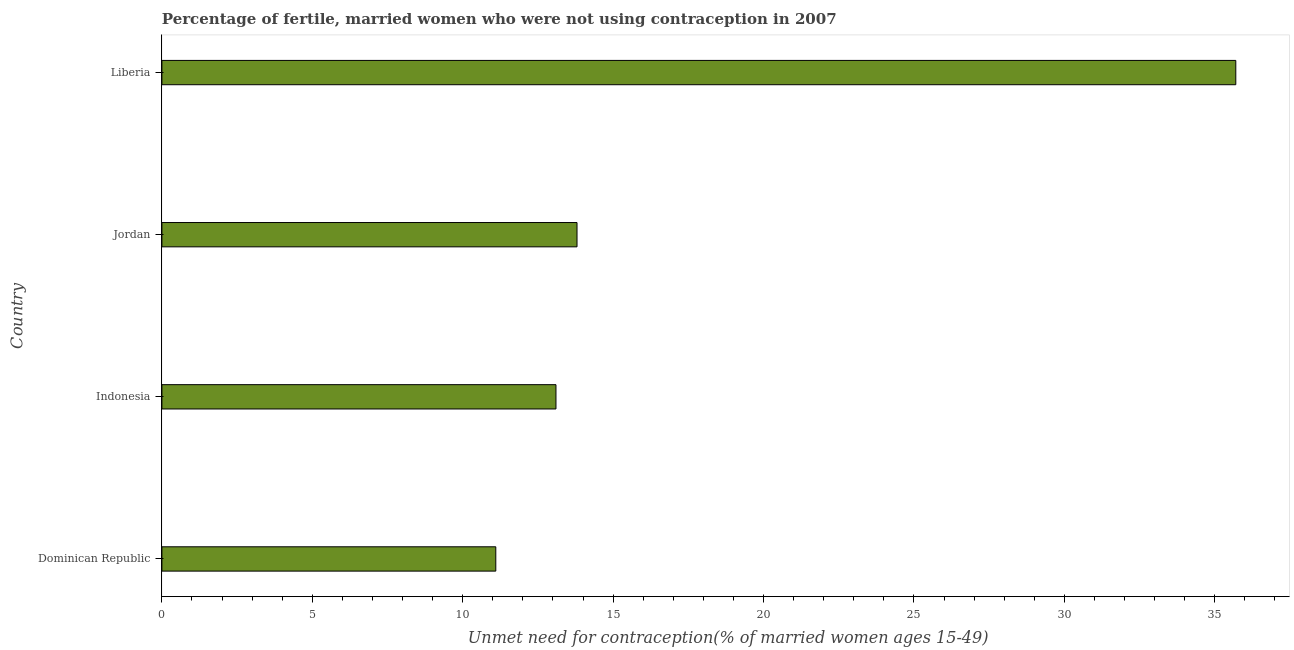Does the graph contain any zero values?
Offer a very short reply. No. What is the title of the graph?
Make the answer very short. Percentage of fertile, married women who were not using contraception in 2007. What is the label or title of the X-axis?
Provide a short and direct response.  Unmet need for contraception(% of married women ages 15-49). Across all countries, what is the maximum number of married women who are not using contraception?
Give a very brief answer. 35.7. In which country was the number of married women who are not using contraception maximum?
Offer a very short reply. Liberia. In which country was the number of married women who are not using contraception minimum?
Keep it short and to the point. Dominican Republic. What is the sum of the number of married women who are not using contraception?
Give a very brief answer. 73.7. What is the average number of married women who are not using contraception per country?
Provide a succinct answer. 18.43. What is the median number of married women who are not using contraception?
Your answer should be very brief. 13.45. In how many countries, is the number of married women who are not using contraception greater than 29 %?
Your answer should be compact. 1. What is the ratio of the number of married women who are not using contraception in Indonesia to that in Jordan?
Provide a succinct answer. 0.95. Is the difference between the number of married women who are not using contraception in Dominican Republic and Jordan greater than the difference between any two countries?
Offer a terse response. No. What is the difference between the highest and the second highest number of married women who are not using contraception?
Offer a very short reply. 21.9. What is the difference between the highest and the lowest number of married women who are not using contraception?
Make the answer very short. 24.6. In how many countries, is the number of married women who are not using contraception greater than the average number of married women who are not using contraception taken over all countries?
Provide a short and direct response. 1. Are all the bars in the graph horizontal?
Give a very brief answer. Yes. How many countries are there in the graph?
Your answer should be compact. 4. What is the difference between two consecutive major ticks on the X-axis?
Ensure brevity in your answer.  5. Are the values on the major ticks of X-axis written in scientific E-notation?
Offer a terse response. No. What is the  Unmet need for contraception(% of married women ages 15-49) of Dominican Republic?
Offer a terse response. 11.1. What is the  Unmet need for contraception(% of married women ages 15-49) in Indonesia?
Your response must be concise. 13.1. What is the  Unmet need for contraception(% of married women ages 15-49) in Jordan?
Offer a terse response. 13.8. What is the  Unmet need for contraception(% of married women ages 15-49) of Liberia?
Provide a succinct answer. 35.7. What is the difference between the  Unmet need for contraception(% of married women ages 15-49) in Dominican Republic and Indonesia?
Your response must be concise. -2. What is the difference between the  Unmet need for contraception(% of married women ages 15-49) in Dominican Republic and Jordan?
Keep it short and to the point. -2.7. What is the difference between the  Unmet need for contraception(% of married women ages 15-49) in Dominican Republic and Liberia?
Offer a very short reply. -24.6. What is the difference between the  Unmet need for contraception(% of married women ages 15-49) in Indonesia and Liberia?
Your answer should be very brief. -22.6. What is the difference between the  Unmet need for contraception(% of married women ages 15-49) in Jordan and Liberia?
Offer a terse response. -21.9. What is the ratio of the  Unmet need for contraception(% of married women ages 15-49) in Dominican Republic to that in Indonesia?
Ensure brevity in your answer.  0.85. What is the ratio of the  Unmet need for contraception(% of married women ages 15-49) in Dominican Republic to that in Jordan?
Ensure brevity in your answer.  0.8. What is the ratio of the  Unmet need for contraception(% of married women ages 15-49) in Dominican Republic to that in Liberia?
Give a very brief answer. 0.31. What is the ratio of the  Unmet need for contraception(% of married women ages 15-49) in Indonesia to that in Jordan?
Provide a short and direct response. 0.95. What is the ratio of the  Unmet need for contraception(% of married women ages 15-49) in Indonesia to that in Liberia?
Give a very brief answer. 0.37. What is the ratio of the  Unmet need for contraception(% of married women ages 15-49) in Jordan to that in Liberia?
Your answer should be very brief. 0.39. 